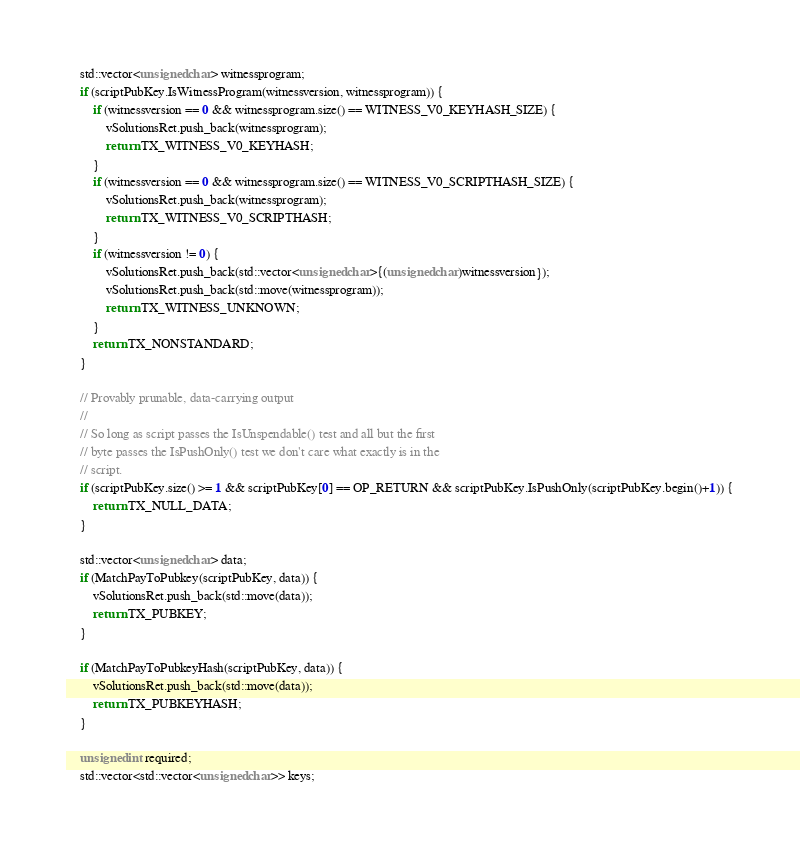Convert code to text. <code><loc_0><loc_0><loc_500><loc_500><_C++_>    std::vector<unsigned char> witnessprogram;
    if (scriptPubKey.IsWitnessProgram(witnessversion, witnessprogram)) {
        if (witnessversion == 0 && witnessprogram.size() == WITNESS_V0_KEYHASH_SIZE) {
            vSolutionsRet.push_back(witnessprogram);
            return TX_WITNESS_V0_KEYHASH;
        }
        if (witnessversion == 0 && witnessprogram.size() == WITNESS_V0_SCRIPTHASH_SIZE) {
            vSolutionsRet.push_back(witnessprogram);
            return TX_WITNESS_V0_SCRIPTHASH;
        }
        if (witnessversion != 0) {
            vSolutionsRet.push_back(std::vector<unsigned char>{(unsigned char)witnessversion});
            vSolutionsRet.push_back(std::move(witnessprogram));
            return TX_WITNESS_UNKNOWN;
        }
        return TX_NONSTANDARD;
    }

    // Provably prunable, data-carrying output
    //
    // So long as script passes the IsUnspendable() test and all but the first
    // byte passes the IsPushOnly() test we don't care what exactly is in the
    // script.
    if (scriptPubKey.size() >= 1 && scriptPubKey[0] == OP_RETURN && scriptPubKey.IsPushOnly(scriptPubKey.begin()+1)) {
        return TX_NULL_DATA;
    }

    std::vector<unsigned char> data;
    if (MatchPayToPubkey(scriptPubKey, data)) {
        vSolutionsRet.push_back(std::move(data));
        return TX_PUBKEY;
    }

    if (MatchPayToPubkeyHash(scriptPubKey, data)) {
        vSolutionsRet.push_back(std::move(data));
        return TX_PUBKEYHASH;
    }

    unsigned int required;
    std::vector<std::vector<unsigned char>> keys;</code> 